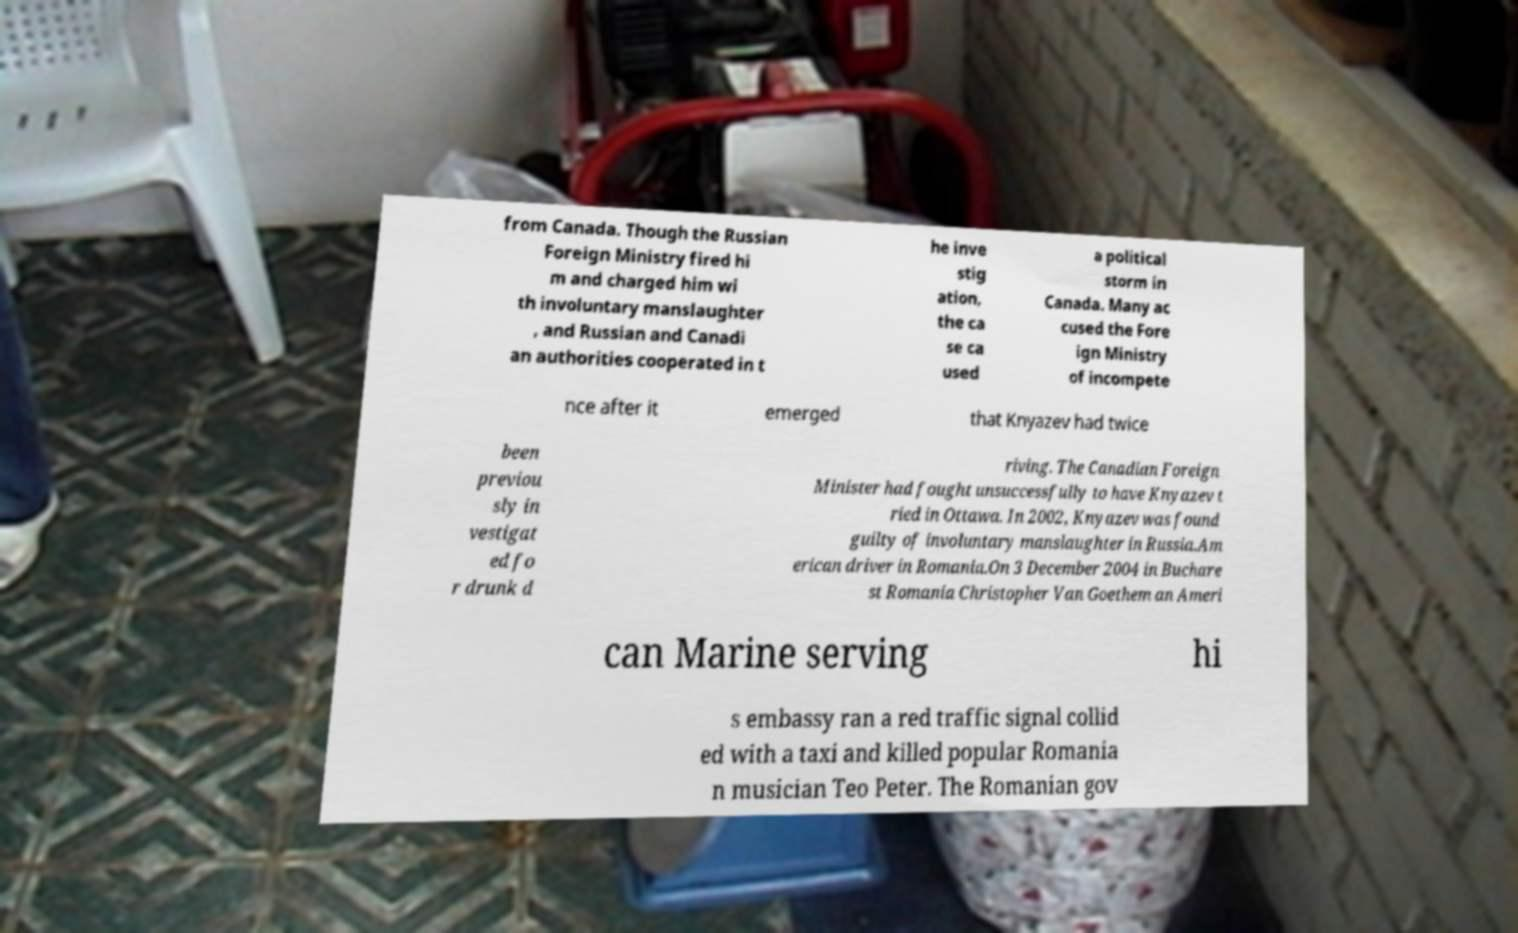Could you assist in decoding the text presented in this image and type it out clearly? from Canada. Though the Russian Foreign Ministry fired hi m and charged him wi th involuntary manslaughter , and Russian and Canadi an authorities cooperated in t he inve stig ation, the ca se ca used a political storm in Canada. Many ac cused the Fore ign Ministry of incompete nce after it emerged that Knyazev had twice been previou sly in vestigat ed fo r drunk d riving. The Canadian Foreign Minister had fought unsuccessfully to have Knyazev t ried in Ottawa. In 2002, Knyazev was found guilty of involuntary manslaughter in Russia.Am erican driver in Romania.On 3 December 2004 in Buchare st Romania Christopher Van Goethem an Ameri can Marine serving hi s embassy ran a red traffic signal collid ed with a taxi and killed popular Romania n musician Teo Peter. The Romanian gov 